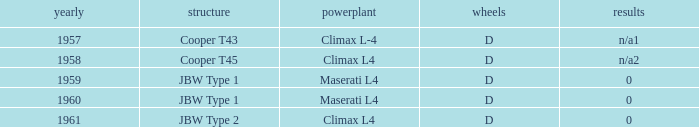What engine was for the vehicle with a cooper t43 chassis? Climax L-4. 